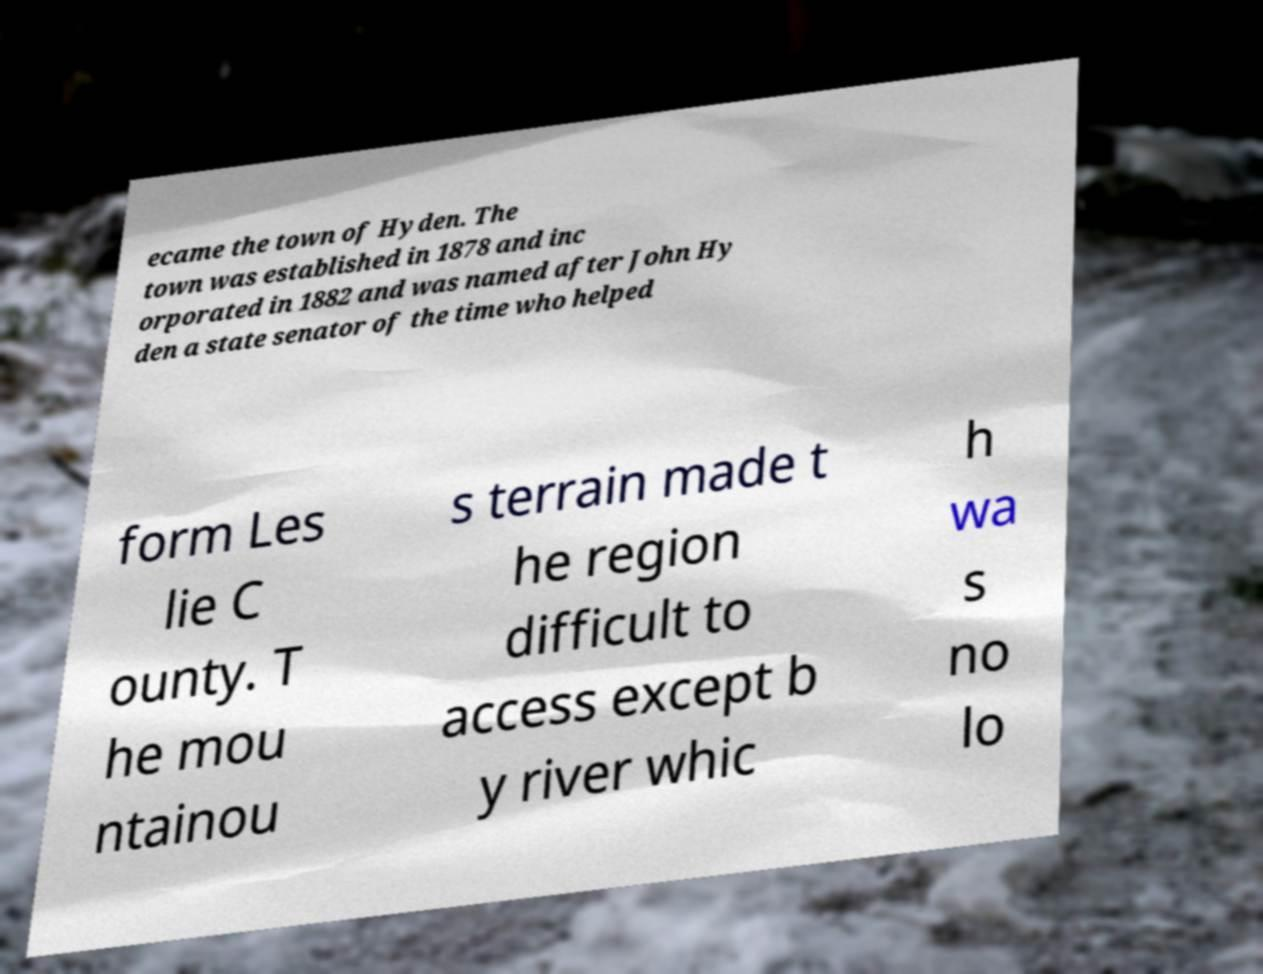Could you assist in decoding the text presented in this image and type it out clearly? ecame the town of Hyden. The town was established in 1878 and inc orporated in 1882 and was named after John Hy den a state senator of the time who helped form Les lie C ounty. T he mou ntainou s terrain made t he region difficult to access except b y river whic h wa s no lo 